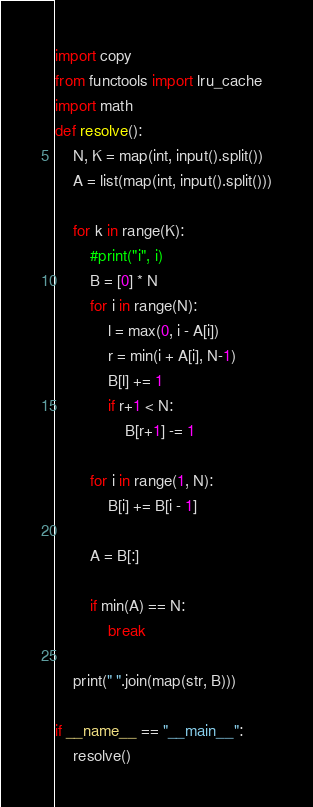<code> <loc_0><loc_0><loc_500><loc_500><_Python_>import copy
from functools import lru_cache
import math
def resolve():
    N, K = map(int, input().split())
    A = list(map(int, input().split()))

    for k in range(K):
        #print("i", i)
        B = [0] * N
        for i in range(N):
            l = max(0, i - A[i])
            r = min(i + A[i], N-1)
            B[l] += 1
            if r+1 < N:
                B[r+1] -= 1

        for i in range(1, N):
            B[i] += B[i - 1] 

        A = B[:]

        if min(A) == N:
            break

    print(" ".join(map(str, B)))

if __name__ == "__main__":
    resolve()</code> 